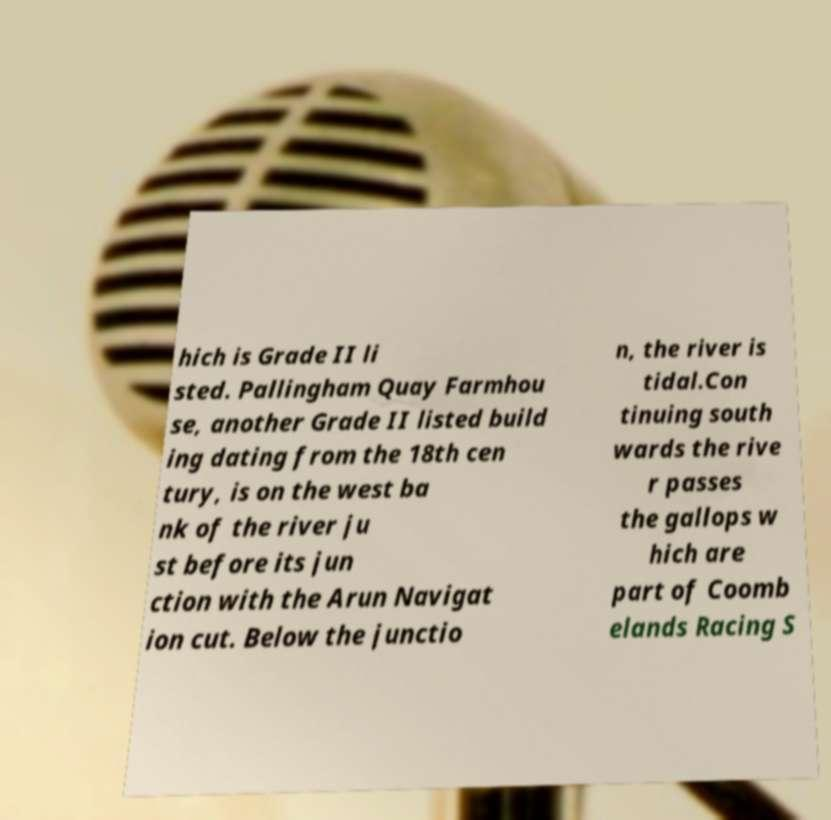Please identify and transcribe the text found in this image. hich is Grade II li sted. Pallingham Quay Farmhou se, another Grade II listed build ing dating from the 18th cen tury, is on the west ba nk of the river ju st before its jun ction with the Arun Navigat ion cut. Below the junctio n, the river is tidal.Con tinuing south wards the rive r passes the gallops w hich are part of Coomb elands Racing S 